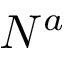Convert formula to latex. <formula><loc_0><loc_0><loc_500><loc_500>N ^ { a }</formula> 